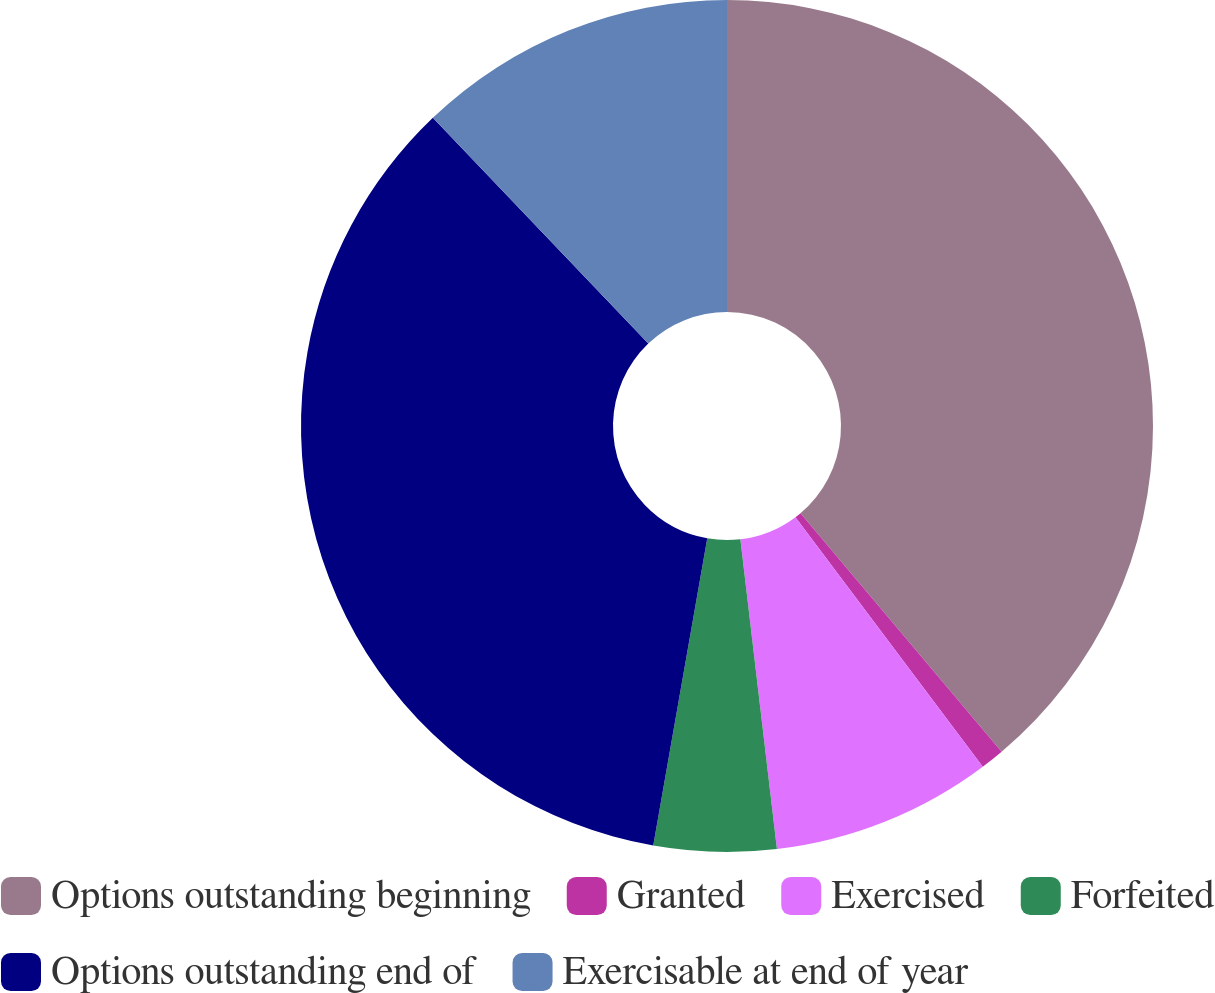Convert chart to OTSL. <chart><loc_0><loc_0><loc_500><loc_500><pie_chart><fcel>Options outstanding beginning<fcel>Granted<fcel>Exercised<fcel>Forfeited<fcel>Options outstanding end of<fcel>Exercisable at end of year<nl><fcel>38.85%<fcel>0.9%<fcel>8.38%<fcel>4.64%<fcel>35.1%<fcel>12.13%<nl></chart> 